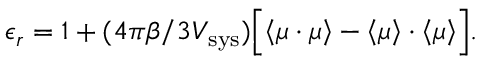Convert formula to latex. <formula><loc_0><loc_0><loc_500><loc_500>\epsilon _ { r } = 1 + ( 4 \pi \beta / 3 V _ { s y s } ) \left [ \left < \mu \cdot \mu \right > - \left < \mu \right > \cdot \left < \mu \right > \right ] .</formula> 